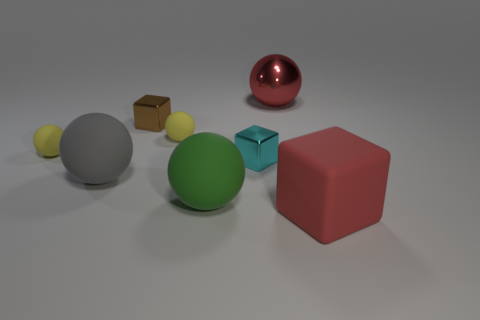What shape is the small yellow rubber object that is on the right side of the yellow rubber sphere that is to the left of the block behind the cyan cube?
Your response must be concise. Sphere. What number of objects are small brown matte balls or large objects that are in front of the green sphere?
Make the answer very short. 1. There is a object that is behind the tiny brown metal block; how big is it?
Your response must be concise. Large. There is a large matte thing that is the same color as the large metallic thing; what is its shape?
Offer a terse response. Cube. Are the large gray object and the red object that is behind the matte block made of the same material?
Give a very brief answer. No. There is a large red object left of the red object right of the red metallic object; how many big gray rubber objects are in front of it?
Keep it short and to the point. 1. What number of yellow objects are either big rubber cubes or large spheres?
Your response must be concise. 0. The red thing that is in front of the big green rubber ball has what shape?
Your answer should be compact. Cube. What is the color of the cube that is the same size as the gray object?
Provide a succinct answer. Red. Is the shape of the tiny cyan object the same as the tiny metal thing that is left of the big green matte thing?
Give a very brief answer. Yes. 